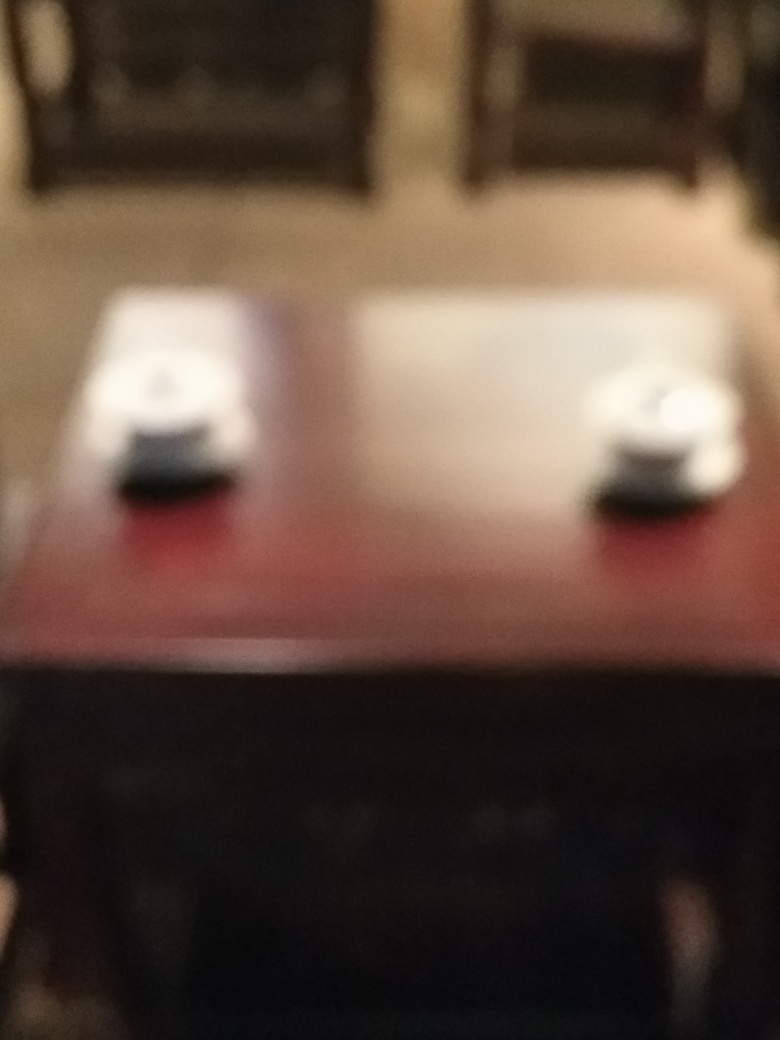What is the quality evaluation of the photo? The photo quality is not optimal. It appears to be out of focus, which results in the image details being blurred, affecting the overall clarity and composition. 